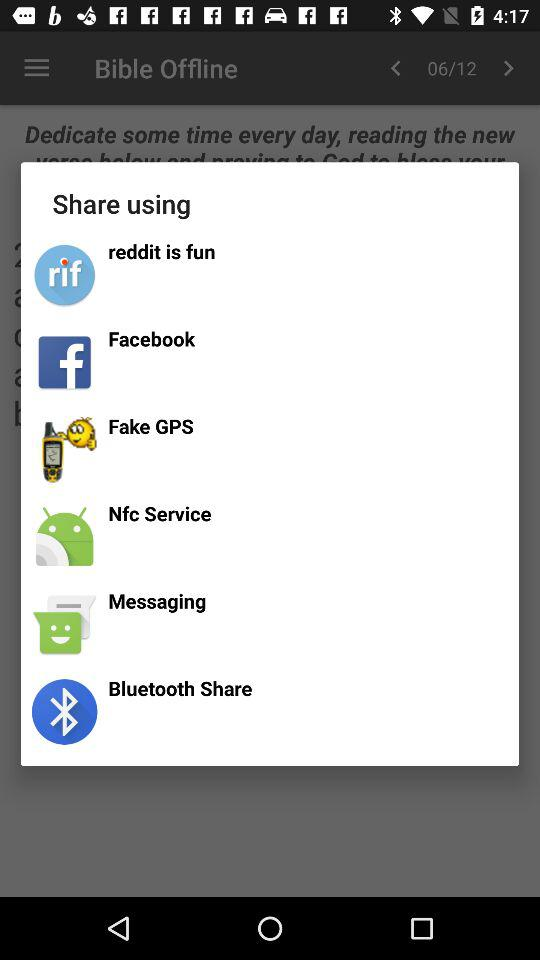How many items are in the share menu?
Answer the question using a single word or phrase. 6 